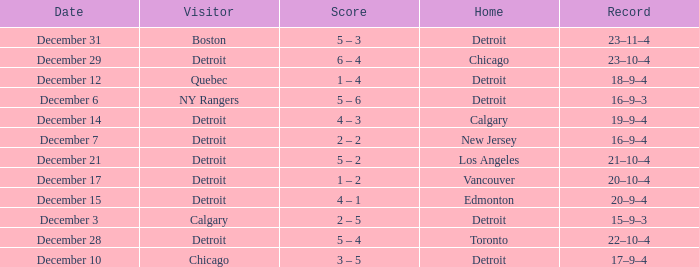I'm looking to parse the entire table for insights. Could you assist me with that? {'header': ['Date', 'Visitor', 'Score', 'Home', 'Record'], 'rows': [['December 31', 'Boston', '5 – 3', 'Detroit', '23–11–4'], ['December 29', 'Detroit', '6 – 4', 'Chicago', '23–10–4'], ['December 12', 'Quebec', '1 – 4', 'Detroit', '18–9–4'], ['December 6', 'NY Rangers', '5 – 6', 'Detroit', '16–9–3'], ['December 14', 'Detroit', '4 – 3', 'Calgary', '19–9–4'], ['December 7', 'Detroit', '2 – 2', 'New Jersey', '16–9–4'], ['December 21', 'Detroit', '5 – 2', 'Los Angeles', '21–10–4'], ['December 17', 'Detroit', '1 – 2', 'Vancouver', '20–10–4'], ['December 15', 'Detroit', '4 – 1', 'Edmonton', '20–9–4'], ['December 3', 'Calgary', '2 – 5', 'Detroit', '15–9–3'], ['December 28', 'Detroit', '5 – 4', 'Toronto', '22–10–4'], ['December 10', 'Chicago', '3 – 5', 'Detroit', '17–9–4']]} Can you tell me the score for december 10th? 3 – 5. 